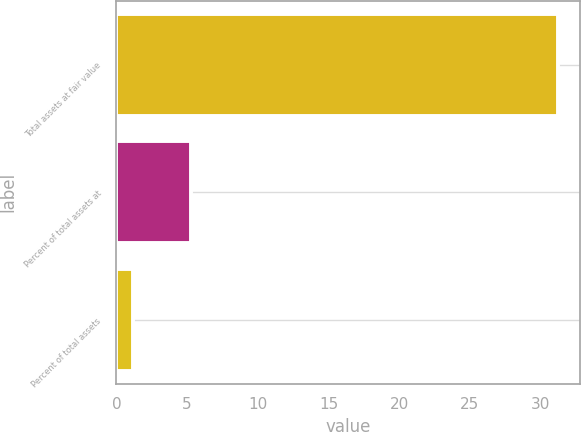Convert chart to OTSL. <chart><loc_0><loc_0><loc_500><loc_500><bar_chart><fcel>Total assets at fair value<fcel>Percent of total assets at<fcel>Percent of total assets<nl><fcel>31.2<fcel>5.3<fcel>1.2<nl></chart> 